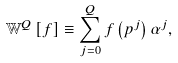Convert formula to latex. <formula><loc_0><loc_0><loc_500><loc_500>\mathbb { W } ^ { Q } \left [ f \right ] \equiv \sum _ { j = 0 } ^ { Q } f \left ( p ^ { j } \right ) \alpha ^ { j } ,</formula> 